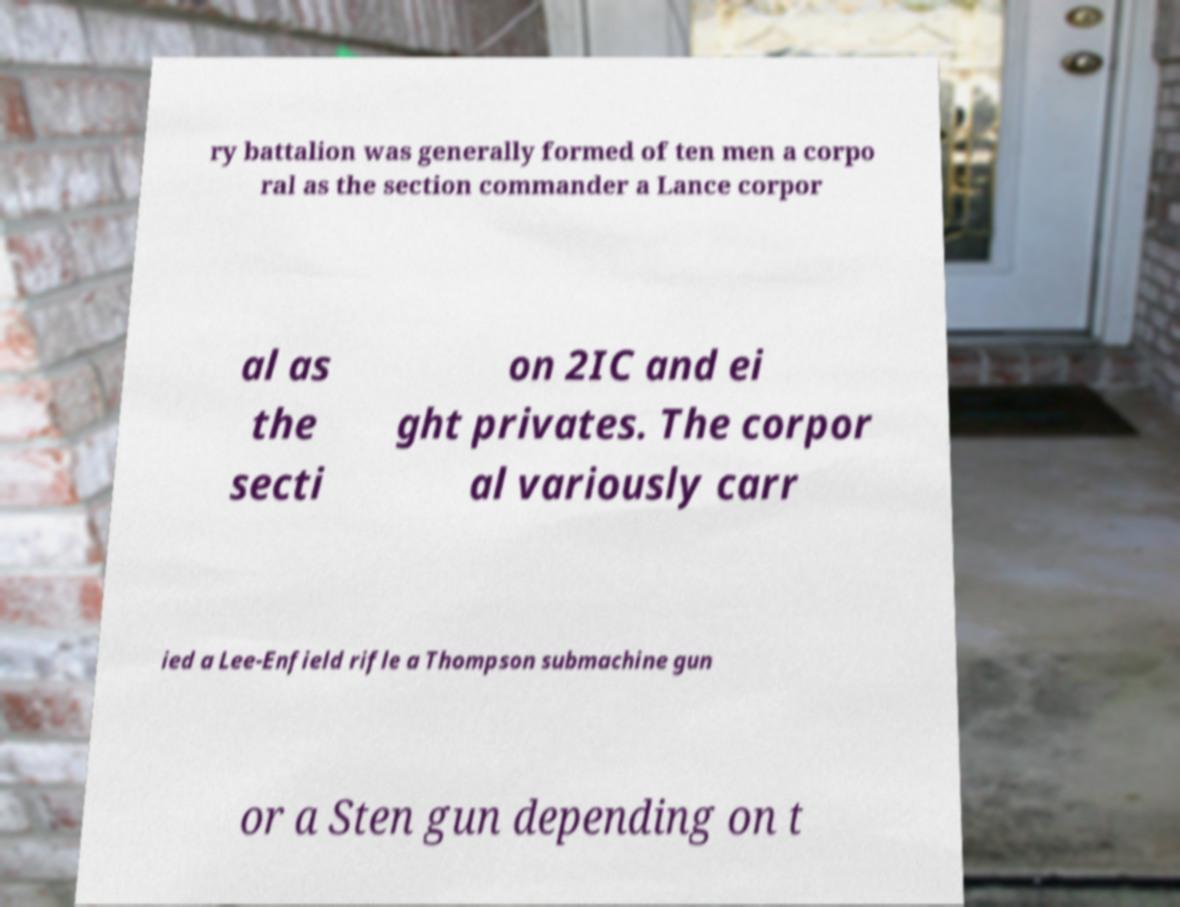There's text embedded in this image that I need extracted. Can you transcribe it verbatim? ry battalion was generally formed of ten men a corpo ral as the section commander a Lance corpor al as the secti on 2IC and ei ght privates. The corpor al variously carr ied a Lee-Enfield rifle a Thompson submachine gun or a Sten gun depending on t 